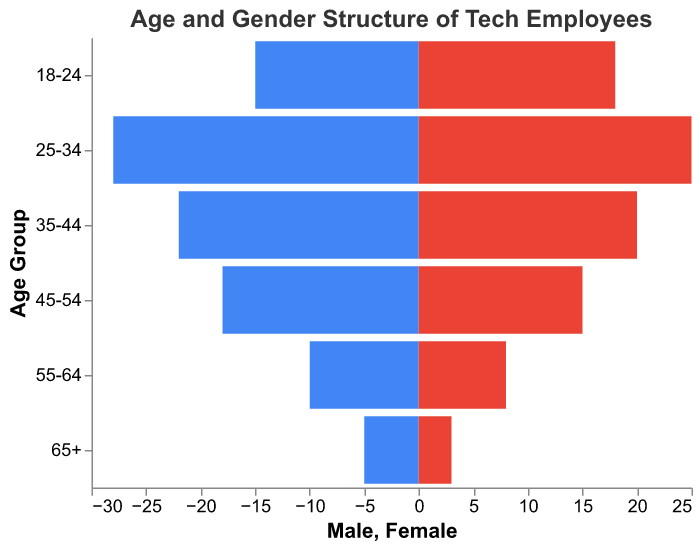What is the age group with the highest number of male employees? The age group with the highest number of male employees can be identified by comparing the values of male employees across different age groups. The group 25-34 has the highest number of male employees, 28.
Answer: 25-34 Which age group has the highest total number of employees? To find the age group with the highest total number of employees, sum the number of male and female employees for each age group and compare. The sum for the group 25-34 is 28 (male) + 25 (female) = 53, which is the highest among all groups.
Answer: 25-34 Which gender has more employees in the age group 35-44? Compare the number of male and female employees in the age group 35-44. Males have 22 and females have 20, so males have more employees.
Answer: Male How many more female employees are there than male employees in the age group 18-24? Calculate the difference between the number of female and male employees in the age group 18-24. The difference is 18 (female) - 15 (male) = 3.
Answer: 3 Which age group has the lowest number of female employees? Identify the age group with the lowest value in the female column. The age group 65+ has the lowest number of female employees, with 3.
Answer: 65+ What is the total number of employees in the 45-54 age group? Sum the number of male and female employees in the age group 45-54. The total is 18 (male) + 15 (female) = 33.
Answer: 33 How does the number of male employees in the 25-34 age group compare to the number of male employees in the 55-64 age group? Compare the number of male employees in the age group 25-34 (28) with the number in the age group 55-64 (10). The 25-34 age group has more male employees.
Answer: More Are there more female employees in the 18-24 age group than male employees in the 35-44 age group? Compare the number of female employees in the 18-24 age group (18) with the number of male employees in the 35-44 age group (22). There are fewer female employees in 18-24.
Answer: No What is the combined total number of male and female employees aged 55 and older? Sum the number of male and female employees for the age groups 55-64 and 65+. The total is 10 (male, 55-64) + 8 (female, 55-64) + 5 (male, 65+) + 3 (female, 65+) = 26.
Answer: 26 